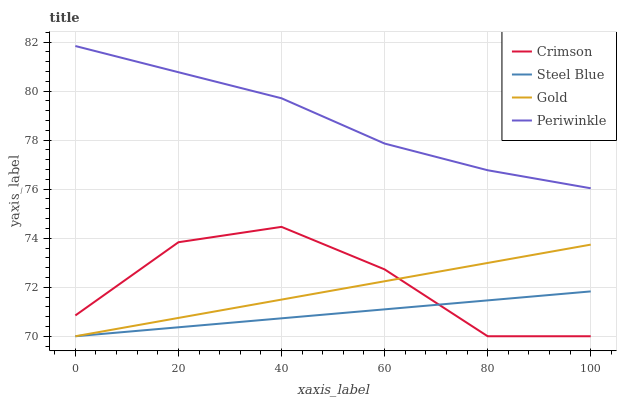Does Steel Blue have the minimum area under the curve?
Answer yes or no. Yes. Does Periwinkle have the maximum area under the curve?
Answer yes or no. Yes. Does Periwinkle have the minimum area under the curve?
Answer yes or no. No. Does Steel Blue have the maximum area under the curve?
Answer yes or no. No. Is Gold the smoothest?
Answer yes or no. Yes. Is Crimson the roughest?
Answer yes or no. Yes. Is Periwinkle the smoothest?
Answer yes or no. No. Is Periwinkle the roughest?
Answer yes or no. No. Does Crimson have the lowest value?
Answer yes or no. Yes. Does Periwinkle have the lowest value?
Answer yes or no. No. Does Periwinkle have the highest value?
Answer yes or no. Yes. Does Steel Blue have the highest value?
Answer yes or no. No. Is Crimson less than Periwinkle?
Answer yes or no. Yes. Is Periwinkle greater than Crimson?
Answer yes or no. Yes. Does Crimson intersect Steel Blue?
Answer yes or no. Yes. Is Crimson less than Steel Blue?
Answer yes or no. No. Is Crimson greater than Steel Blue?
Answer yes or no. No. Does Crimson intersect Periwinkle?
Answer yes or no. No. 